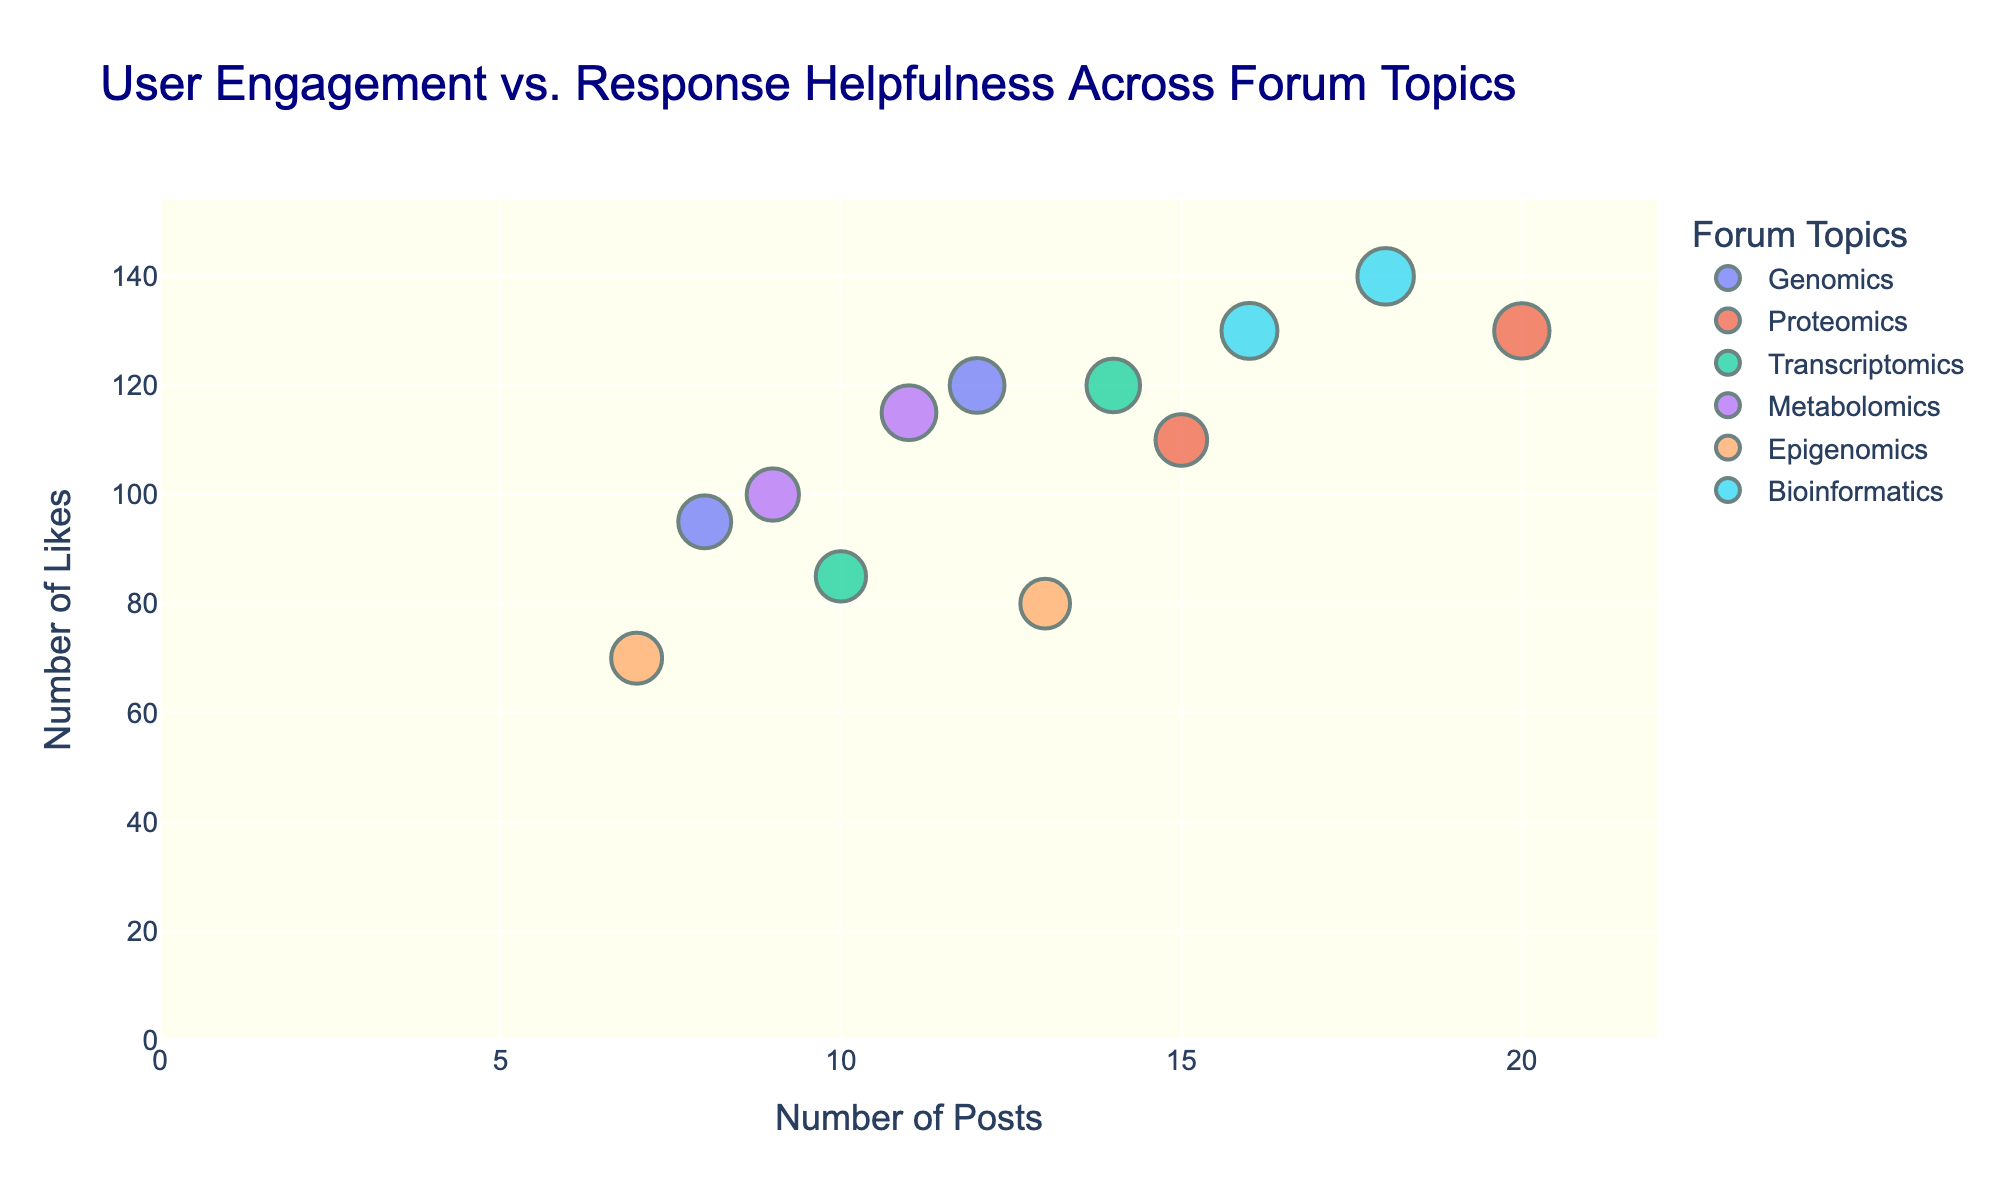What is the title of the figure? The title is displayed at the top of the figure in larger, darker blue font. It reads "User Engagement vs. Response Helpfulness Across Forum Topics."
Answer: User Engagement vs. Response Helpfulness Across Forum Topics Which axis represents the number of posts? The x-axis represents the number of posts, as indicated by the label "Number of Posts" beneath the horizontal axis.
Answer: x-axis What is the color coding in the scatter plot representing? The different colors of the data points represent different forum topics. The color legend on the right side of the figure shows this mapping.
Answer: Forum topics Who has the highest number of likes in the "Bioinformatics" topic? To find this, look for data points with the "Bioinformatics" label in the legend, and check their y-values on "Number of Likes." Sam.Johnson has 140 likes, which is the highest in this topic.
Answer: Sam.Johnson What is the range of response helpfulness scores visualized in the plot? The legend at the right side of the plot shows the color bar for "Response Helpfulness," indicating a range from approximately 3.7 to 4.8.
Answer: 3.7 to 4.8 Compare the user engagement (Likes) between Nina.Kim in "Transcriptomics" and Alice.Wong in "Proteomics." Who has more likes? Nina.Kim has 120 likes in "Transcriptomics," while Alice.Wong has 130 likes in "Proteomics." Alice.Wong has more likes.
Answer: Alice.Wong What is the average number of response helpfulness in the "Genomics" topic? In the "Genomics" topic, Dave.Smith has a helpfulness score of 4.5 and Susan.Lee has 4.2. The average is calculated as (4.5 + 4.2) / 2 = 4.35.
Answer: 4.35 Assuming "Response Helpfulness" influences the size of the marker, who has the largest marker size in the "Metabolomics" topic and what is their helpfulness score? In "Metabolomics," Linda.Green's marker is larger than Kevin.Brown's. Linda.Green has a Response Helpfulness score of 4.5, which is higher than Kevin.Brown's 4.1.
Answer: Linda.Green, 4.5 Which forum topic has the least number of posts overall, and what are their cumulative posts? "Epigenomics" has the least number of posts overall. Peter.White has 13 posts, and Jenny.Smith has 7 posts. Cumulatively, that's 13 + 7 = 20 posts.
Answer: Epigenomics, 20 How many users have a Response Helpfulness score greater than 4.5? By examining the marker sizes and values in the "Response Helpfulness" data, we find three users with scores greater than 4.5: Alice.Wong in "Proteomics," Sam.Johnson in "Bioinformatics," and Nancy.Lopez in "Bioinformatics."
Answer: 3 